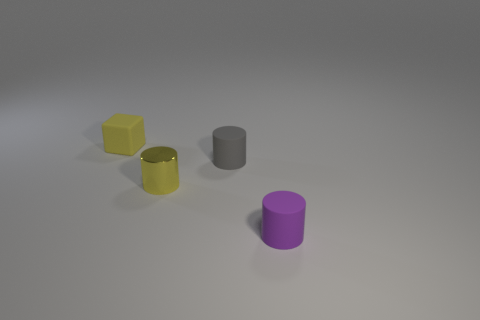Subtract all small purple rubber cylinders. How many cylinders are left? 2 Add 2 small cylinders. How many objects exist? 6 Subtract all cubes. How many objects are left? 3 Subtract all green cylinders. Subtract all yellow spheres. How many cylinders are left? 3 Add 2 small yellow rubber objects. How many small yellow rubber objects are left? 3 Add 1 green blocks. How many green blocks exist? 1 Subtract 1 yellow cubes. How many objects are left? 3 Subtract all shiny cylinders. Subtract all rubber cylinders. How many objects are left? 1 